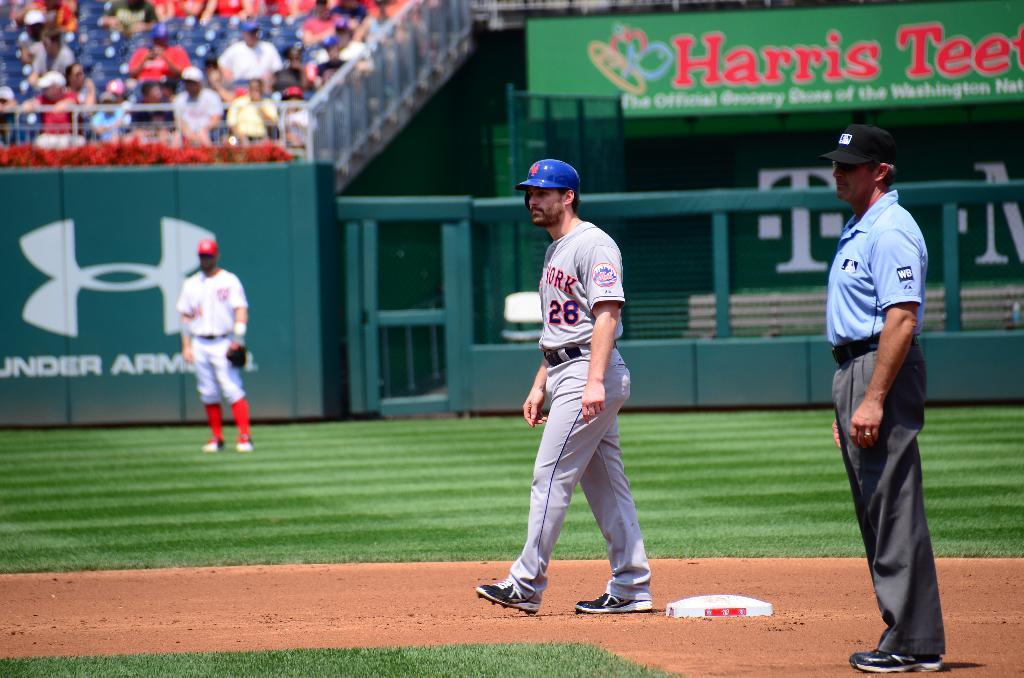<image>
Share a concise interpretation of the image provided. A baseball player wears a uniform with New York on the chest. 